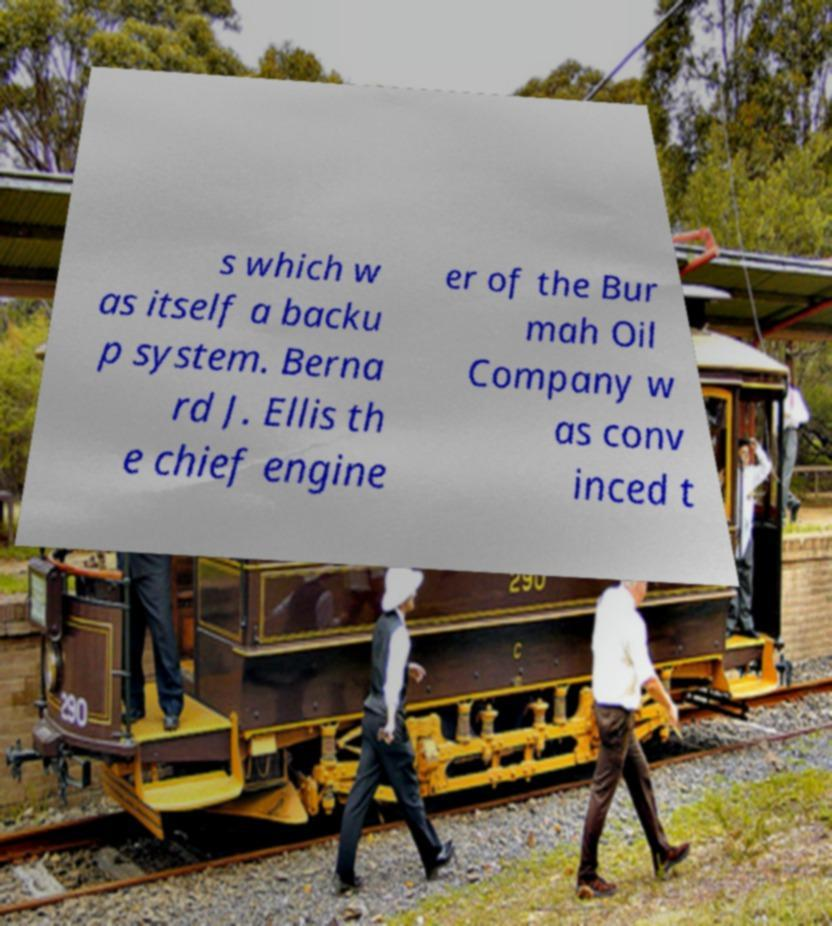Please read and relay the text visible in this image. What does it say? s which w as itself a backu p system. Berna rd J. Ellis th e chief engine er of the Bur mah Oil Company w as conv inced t 